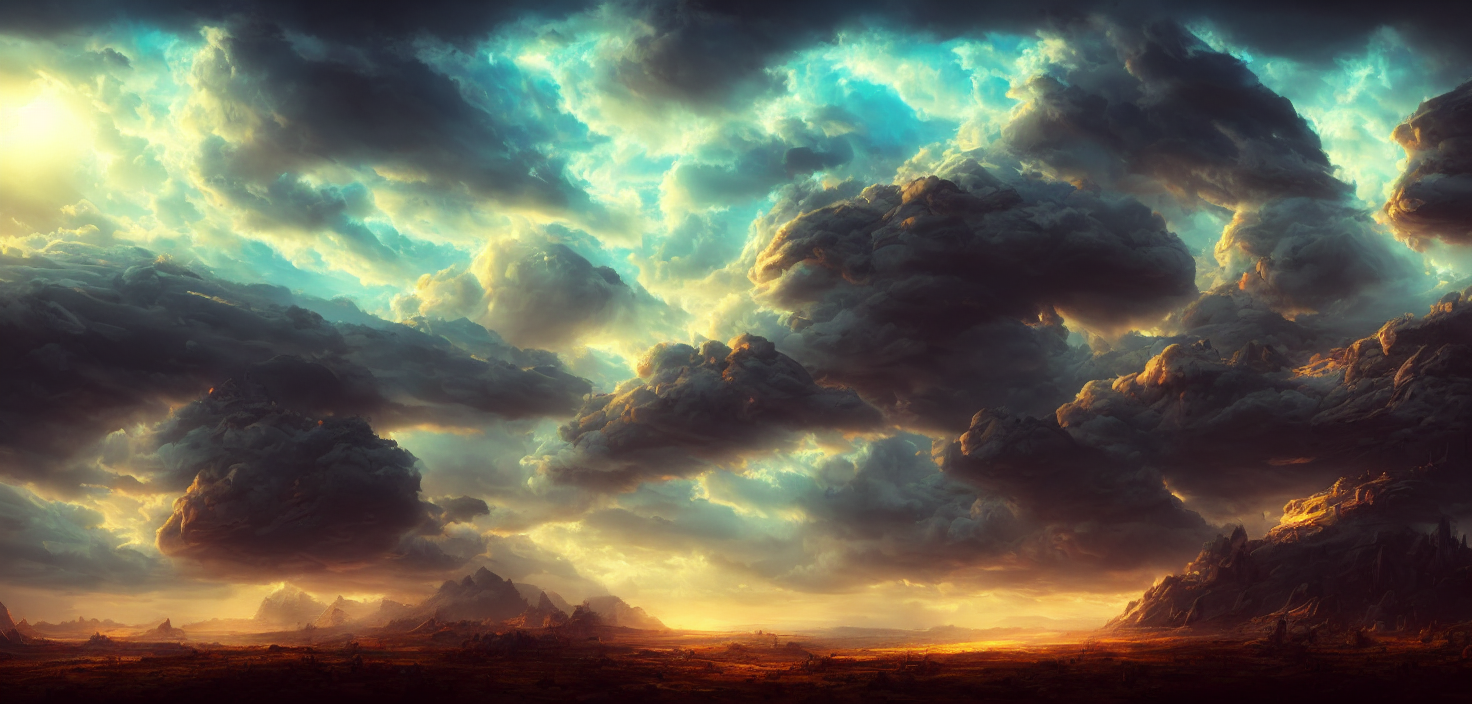What time of day does this image represent, and how can you tell? It appears to be either dawn or dusk, as indicated by the sun's position near the horizon. The warm hues near the land contrast with the cooler tones in the sky, typical of the 'golden hour' when the sun is low in the sky. What types of clouds are shown in the image, and what do they signify? The clouds look to be cumulonimbus, which are often associated with thunderstorms and heavy precipitation. Their towering presence and dark bases hint at their potential to unleash significant weather phenomena. 